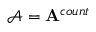Convert formula to latex. <formula><loc_0><loc_0><loc_500><loc_500>\mathcal { A } = A ^ { c o u n t }</formula> 